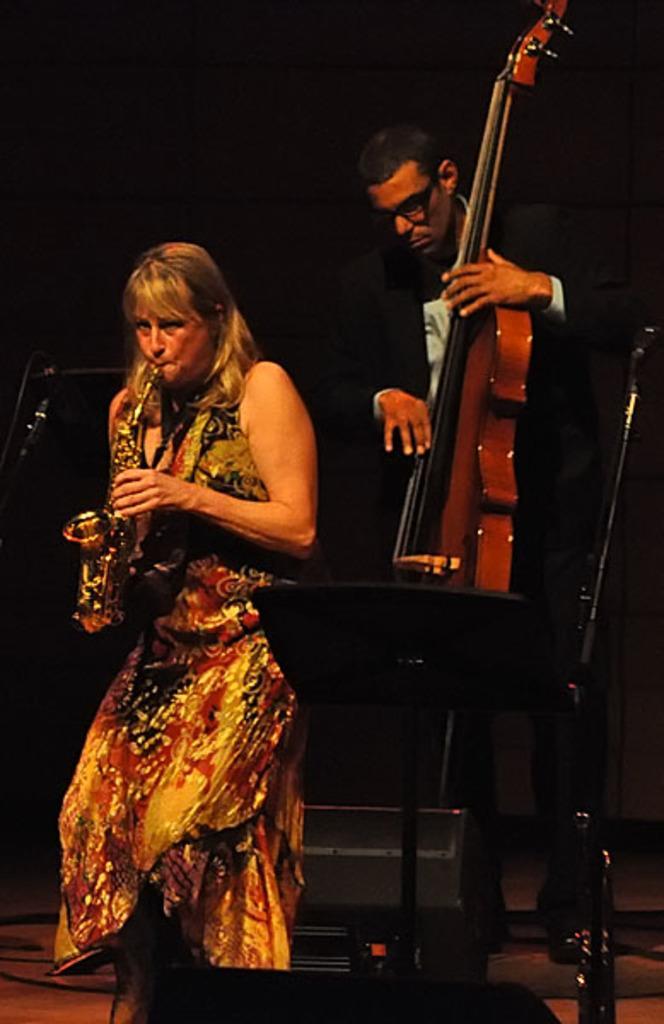Describe this image in one or two sentences. In this picture there is a lady on the left side of the image, by holding a trumpet in her hands and there is a man who is standing on the right side of the image, by holding a guitar in his hands. 